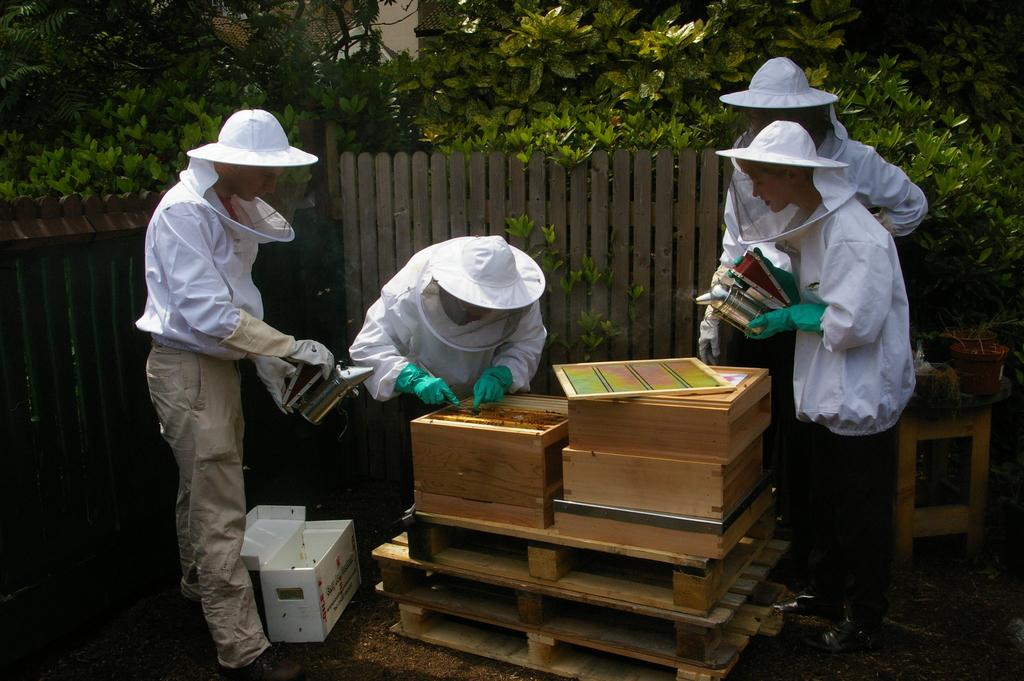What is the main subject of the image? The main subject of the image is a group of boys. What are the boys wearing in the image? The boys are wearing white color jackets and net caps in the image. What activity are the boys engaged in? The boys are trying to open honey bee boxes in the image. What can be seen in the background of the image? There is wooden fencing and plants visible in the image. What type of rake is being used to attract the honey bees in the image? There is no rake present in the image, and the boys are not using any tools to attract the honey bees. 